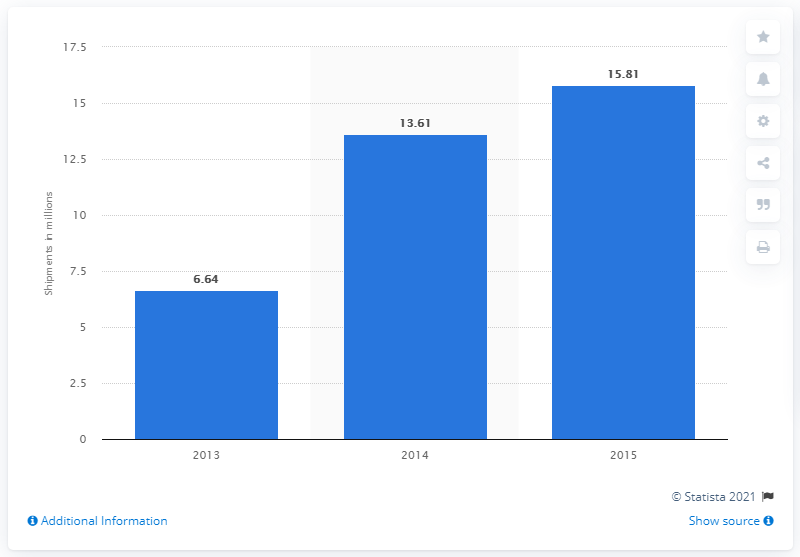Outline some significant characteristics in this image. The difference in shipment between 2014 and 2013 is 6.97. In 2015, shipments reached their highest level. 